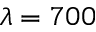Convert formula to latex. <formula><loc_0><loc_0><loc_500><loc_500>\lambda = 7 0 0</formula> 